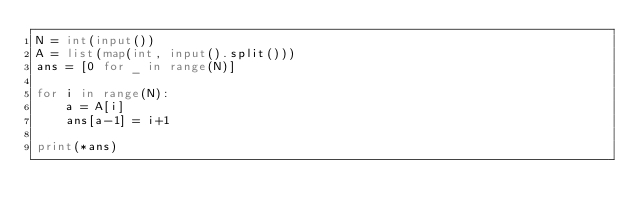Convert code to text. <code><loc_0><loc_0><loc_500><loc_500><_Python_>N = int(input())
A = list(map(int, input().split()))
ans = [0 for _ in range(N)]

for i in range(N):
    a = A[i]
    ans[a-1] = i+1

print(*ans)
</code> 